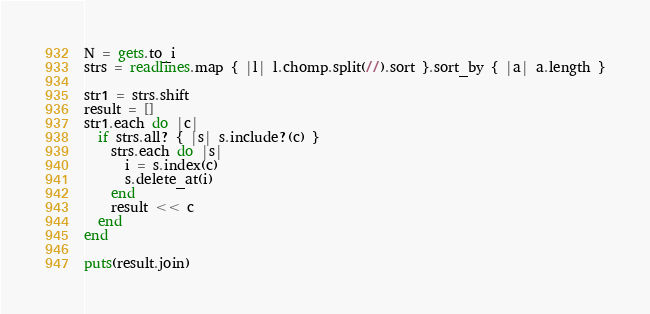Convert code to text. <code><loc_0><loc_0><loc_500><loc_500><_Ruby_>N = gets.to_i
strs = readlines.map { |l| l.chomp.split(//).sort }.sort_by { |a| a.length }
 
str1 = strs.shift
result = []
str1.each do |c|
  if strs.all? { |s| s.include?(c) }
    strs.each do |s|
      i = s.index(c)
      s.delete_at(i)
    end
    result << c
  end
end
 
puts(result.join)</code> 